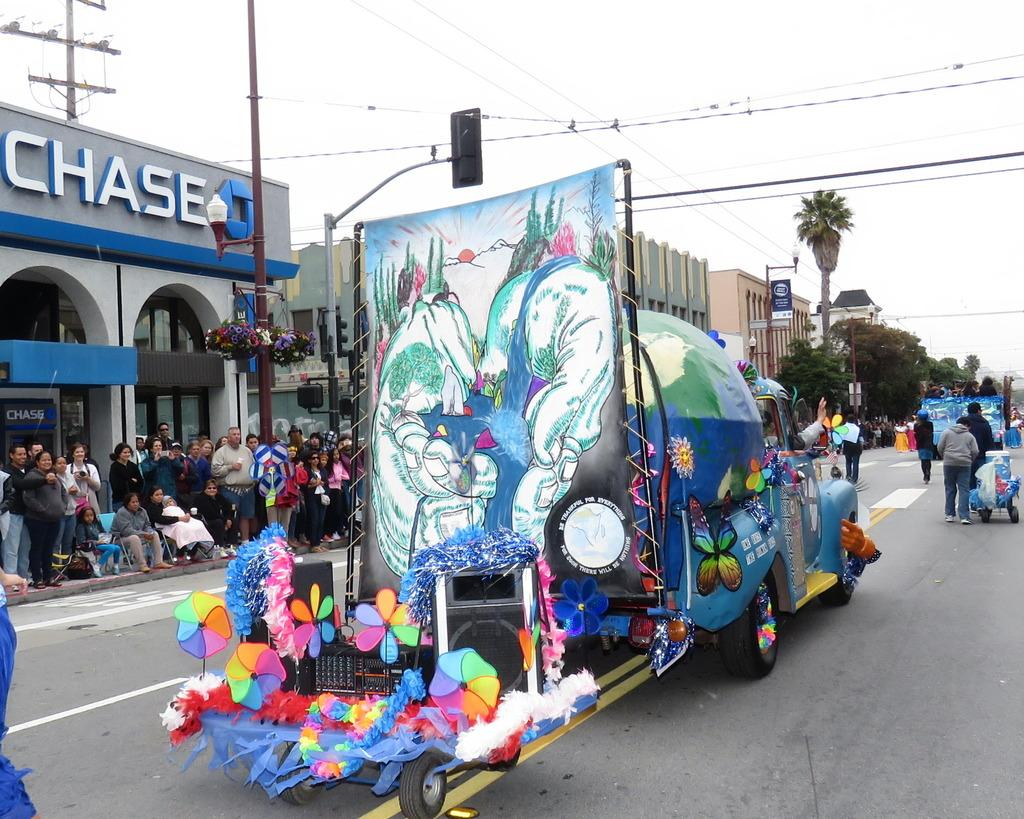<image>
Provide a brief description of the given image. A colorfull float alongside a building that says Chase on it. 